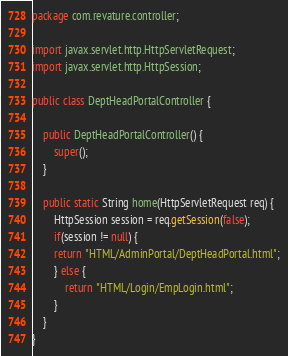<code> <loc_0><loc_0><loc_500><loc_500><_Java_>package com.revature.controller;

import javax.servlet.http.HttpServletRequest;
import javax.servlet.http.HttpSession;

public class DeptHeadPortalController {

	public DeptHeadPortalController() {
		super();
	}
	
	public static String home(HttpServletRequest req) {
		HttpSession session = req.getSession(false);
		if(session != null) {
		return "HTML/AdminPortal/DeptHeadPortal.html";
		} else {
			return "HTML/Login/EmpLogin.html";
		}
	}
}</code> 